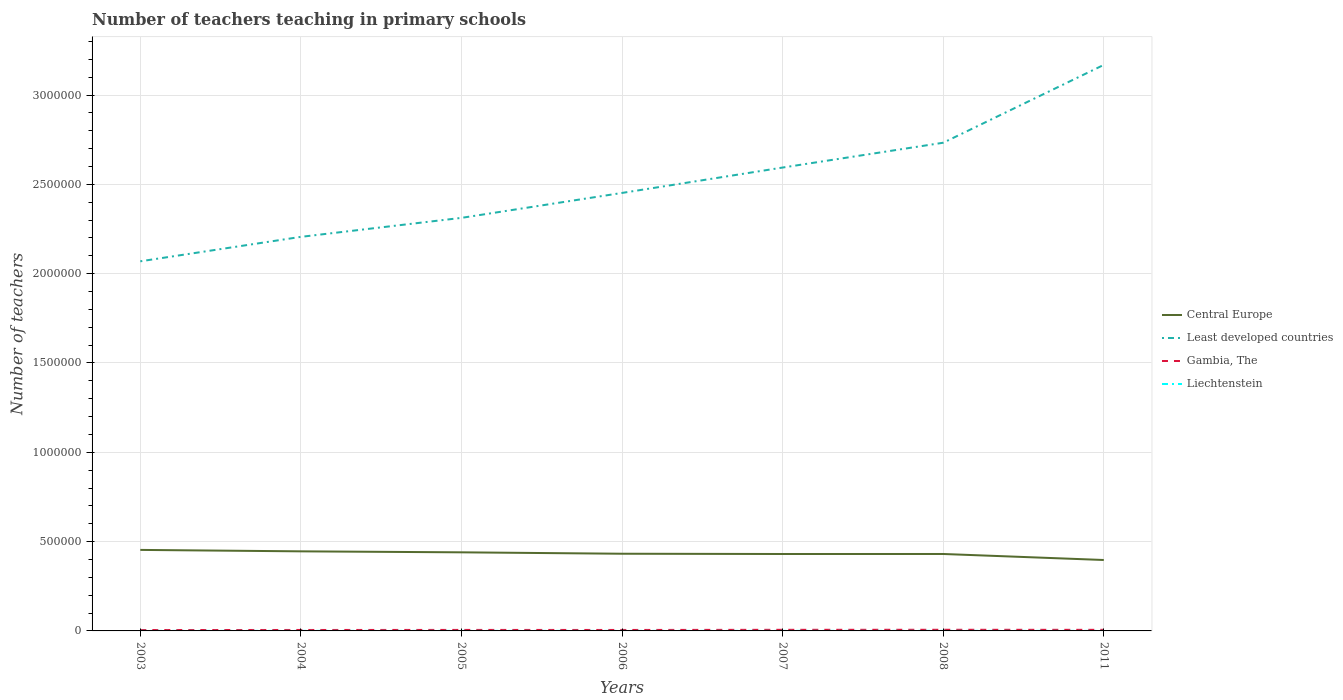How many different coloured lines are there?
Your response must be concise. 4. Is the number of lines equal to the number of legend labels?
Make the answer very short. Yes. Across all years, what is the maximum number of teachers teaching in primary schools in Liechtenstein?
Offer a terse response. 242. What is the difference between the highest and the second highest number of teachers teaching in primary schools in Least developed countries?
Your answer should be very brief. 1.10e+06. What is the difference between the highest and the lowest number of teachers teaching in primary schools in Central Europe?
Provide a succinct answer. 3. Is the number of teachers teaching in primary schools in Central Europe strictly greater than the number of teachers teaching in primary schools in Gambia, The over the years?
Provide a short and direct response. No. How many lines are there?
Ensure brevity in your answer.  4. How many years are there in the graph?
Offer a terse response. 7. How are the legend labels stacked?
Provide a short and direct response. Vertical. What is the title of the graph?
Ensure brevity in your answer.  Number of teachers teaching in primary schools. Does "Japan" appear as one of the legend labels in the graph?
Give a very brief answer. No. What is the label or title of the X-axis?
Provide a succinct answer. Years. What is the label or title of the Y-axis?
Make the answer very short. Number of teachers. What is the Number of teachers of Central Europe in 2003?
Make the answer very short. 4.54e+05. What is the Number of teachers in Least developed countries in 2003?
Your response must be concise. 2.07e+06. What is the Number of teachers in Gambia, The in 2003?
Provide a short and direct response. 4985. What is the Number of teachers of Liechtenstein in 2003?
Your answer should be very brief. 242. What is the Number of teachers of Central Europe in 2004?
Offer a very short reply. 4.45e+05. What is the Number of teachers of Least developed countries in 2004?
Your response must be concise. 2.21e+06. What is the Number of teachers in Gambia, The in 2004?
Give a very brief answer. 5313. What is the Number of teachers in Liechtenstein in 2004?
Your response must be concise. 260. What is the Number of teachers in Central Europe in 2005?
Your answer should be very brief. 4.40e+05. What is the Number of teachers in Least developed countries in 2005?
Ensure brevity in your answer.  2.31e+06. What is the Number of teachers of Gambia, The in 2005?
Your response must be concise. 5616. What is the Number of teachers of Liechtenstein in 2005?
Ensure brevity in your answer.  260. What is the Number of teachers of Central Europe in 2006?
Offer a terse response. 4.32e+05. What is the Number of teachers of Least developed countries in 2006?
Give a very brief answer. 2.45e+06. What is the Number of teachers of Gambia, The in 2006?
Offer a terse response. 5392. What is the Number of teachers of Liechtenstein in 2006?
Offer a very short reply. 268. What is the Number of teachers in Central Europe in 2007?
Give a very brief answer. 4.31e+05. What is the Number of teachers in Least developed countries in 2007?
Keep it short and to the point. 2.59e+06. What is the Number of teachers of Gambia, The in 2007?
Your answer should be compact. 6219. What is the Number of teachers in Liechtenstein in 2007?
Your response must be concise. 315. What is the Number of teachers of Central Europe in 2008?
Give a very brief answer. 4.31e+05. What is the Number of teachers in Least developed countries in 2008?
Keep it short and to the point. 2.73e+06. What is the Number of teachers of Gambia, The in 2008?
Ensure brevity in your answer.  6429. What is the Number of teachers in Liechtenstein in 2008?
Provide a short and direct response. 332. What is the Number of teachers of Central Europe in 2011?
Your answer should be compact. 3.97e+05. What is the Number of teachers of Least developed countries in 2011?
Your answer should be very brief. 3.17e+06. What is the Number of teachers of Gambia, The in 2011?
Offer a terse response. 6074. What is the Number of teachers of Liechtenstein in 2011?
Ensure brevity in your answer.  257. Across all years, what is the maximum Number of teachers in Central Europe?
Ensure brevity in your answer.  4.54e+05. Across all years, what is the maximum Number of teachers of Least developed countries?
Give a very brief answer. 3.17e+06. Across all years, what is the maximum Number of teachers in Gambia, The?
Offer a terse response. 6429. Across all years, what is the maximum Number of teachers in Liechtenstein?
Your answer should be compact. 332. Across all years, what is the minimum Number of teachers of Central Europe?
Provide a succinct answer. 3.97e+05. Across all years, what is the minimum Number of teachers in Least developed countries?
Ensure brevity in your answer.  2.07e+06. Across all years, what is the minimum Number of teachers in Gambia, The?
Ensure brevity in your answer.  4985. Across all years, what is the minimum Number of teachers of Liechtenstein?
Keep it short and to the point. 242. What is the total Number of teachers in Central Europe in the graph?
Your response must be concise. 3.03e+06. What is the total Number of teachers in Least developed countries in the graph?
Give a very brief answer. 1.75e+07. What is the total Number of teachers of Gambia, The in the graph?
Keep it short and to the point. 4.00e+04. What is the total Number of teachers of Liechtenstein in the graph?
Give a very brief answer. 1934. What is the difference between the Number of teachers in Central Europe in 2003 and that in 2004?
Keep it short and to the point. 8121.78. What is the difference between the Number of teachers of Least developed countries in 2003 and that in 2004?
Your response must be concise. -1.37e+05. What is the difference between the Number of teachers of Gambia, The in 2003 and that in 2004?
Provide a succinct answer. -328. What is the difference between the Number of teachers of Liechtenstein in 2003 and that in 2004?
Give a very brief answer. -18. What is the difference between the Number of teachers of Central Europe in 2003 and that in 2005?
Your response must be concise. 1.36e+04. What is the difference between the Number of teachers of Least developed countries in 2003 and that in 2005?
Offer a very short reply. -2.43e+05. What is the difference between the Number of teachers in Gambia, The in 2003 and that in 2005?
Ensure brevity in your answer.  -631. What is the difference between the Number of teachers in Central Europe in 2003 and that in 2006?
Give a very brief answer. 2.15e+04. What is the difference between the Number of teachers of Least developed countries in 2003 and that in 2006?
Provide a succinct answer. -3.83e+05. What is the difference between the Number of teachers in Gambia, The in 2003 and that in 2006?
Your answer should be compact. -407. What is the difference between the Number of teachers in Central Europe in 2003 and that in 2007?
Your answer should be compact. 2.30e+04. What is the difference between the Number of teachers in Least developed countries in 2003 and that in 2007?
Provide a succinct answer. -5.25e+05. What is the difference between the Number of teachers of Gambia, The in 2003 and that in 2007?
Make the answer very short. -1234. What is the difference between the Number of teachers in Liechtenstein in 2003 and that in 2007?
Keep it short and to the point. -73. What is the difference between the Number of teachers of Central Europe in 2003 and that in 2008?
Your response must be concise. 2.29e+04. What is the difference between the Number of teachers in Least developed countries in 2003 and that in 2008?
Provide a short and direct response. -6.64e+05. What is the difference between the Number of teachers of Gambia, The in 2003 and that in 2008?
Keep it short and to the point. -1444. What is the difference between the Number of teachers of Liechtenstein in 2003 and that in 2008?
Keep it short and to the point. -90. What is the difference between the Number of teachers in Central Europe in 2003 and that in 2011?
Provide a succinct answer. 5.65e+04. What is the difference between the Number of teachers of Least developed countries in 2003 and that in 2011?
Your answer should be compact. -1.10e+06. What is the difference between the Number of teachers of Gambia, The in 2003 and that in 2011?
Make the answer very short. -1089. What is the difference between the Number of teachers of Central Europe in 2004 and that in 2005?
Give a very brief answer. 5439.44. What is the difference between the Number of teachers in Least developed countries in 2004 and that in 2005?
Provide a short and direct response. -1.06e+05. What is the difference between the Number of teachers of Gambia, The in 2004 and that in 2005?
Your answer should be compact. -303. What is the difference between the Number of teachers in Central Europe in 2004 and that in 2006?
Offer a terse response. 1.34e+04. What is the difference between the Number of teachers in Least developed countries in 2004 and that in 2006?
Give a very brief answer. -2.46e+05. What is the difference between the Number of teachers in Gambia, The in 2004 and that in 2006?
Provide a succinct answer. -79. What is the difference between the Number of teachers in Liechtenstein in 2004 and that in 2006?
Give a very brief answer. -8. What is the difference between the Number of teachers in Central Europe in 2004 and that in 2007?
Your response must be concise. 1.49e+04. What is the difference between the Number of teachers in Least developed countries in 2004 and that in 2007?
Provide a short and direct response. -3.88e+05. What is the difference between the Number of teachers in Gambia, The in 2004 and that in 2007?
Keep it short and to the point. -906. What is the difference between the Number of teachers in Liechtenstein in 2004 and that in 2007?
Provide a short and direct response. -55. What is the difference between the Number of teachers in Central Europe in 2004 and that in 2008?
Provide a succinct answer. 1.47e+04. What is the difference between the Number of teachers in Least developed countries in 2004 and that in 2008?
Ensure brevity in your answer.  -5.27e+05. What is the difference between the Number of teachers in Gambia, The in 2004 and that in 2008?
Provide a short and direct response. -1116. What is the difference between the Number of teachers in Liechtenstein in 2004 and that in 2008?
Make the answer very short. -72. What is the difference between the Number of teachers in Central Europe in 2004 and that in 2011?
Ensure brevity in your answer.  4.84e+04. What is the difference between the Number of teachers in Least developed countries in 2004 and that in 2011?
Make the answer very short. -9.63e+05. What is the difference between the Number of teachers in Gambia, The in 2004 and that in 2011?
Your answer should be very brief. -761. What is the difference between the Number of teachers of Liechtenstein in 2004 and that in 2011?
Provide a succinct answer. 3. What is the difference between the Number of teachers in Central Europe in 2005 and that in 2006?
Offer a very short reply. 7940.81. What is the difference between the Number of teachers of Least developed countries in 2005 and that in 2006?
Keep it short and to the point. -1.40e+05. What is the difference between the Number of teachers of Gambia, The in 2005 and that in 2006?
Ensure brevity in your answer.  224. What is the difference between the Number of teachers in Liechtenstein in 2005 and that in 2006?
Provide a short and direct response. -8. What is the difference between the Number of teachers in Central Europe in 2005 and that in 2007?
Offer a terse response. 9410.81. What is the difference between the Number of teachers of Least developed countries in 2005 and that in 2007?
Provide a succinct answer. -2.82e+05. What is the difference between the Number of teachers of Gambia, The in 2005 and that in 2007?
Your response must be concise. -603. What is the difference between the Number of teachers of Liechtenstein in 2005 and that in 2007?
Keep it short and to the point. -55. What is the difference between the Number of teachers in Central Europe in 2005 and that in 2008?
Ensure brevity in your answer.  9306.81. What is the difference between the Number of teachers of Least developed countries in 2005 and that in 2008?
Your response must be concise. -4.21e+05. What is the difference between the Number of teachers of Gambia, The in 2005 and that in 2008?
Ensure brevity in your answer.  -813. What is the difference between the Number of teachers of Liechtenstein in 2005 and that in 2008?
Offer a terse response. -72. What is the difference between the Number of teachers of Central Europe in 2005 and that in 2011?
Offer a terse response. 4.30e+04. What is the difference between the Number of teachers in Least developed countries in 2005 and that in 2011?
Offer a terse response. -8.56e+05. What is the difference between the Number of teachers of Gambia, The in 2005 and that in 2011?
Provide a succinct answer. -458. What is the difference between the Number of teachers in Liechtenstein in 2005 and that in 2011?
Your answer should be compact. 3. What is the difference between the Number of teachers in Central Europe in 2006 and that in 2007?
Keep it short and to the point. 1470. What is the difference between the Number of teachers in Least developed countries in 2006 and that in 2007?
Make the answer very short. -1.42e+05. What is the difference between the Number of teachers of Gambia, The in 2006 and that in 2007?
Ensure brevity in your answer.  -827. What is the difference between the Number of teachers in Liechtenstein in 2006 and that in 2007?
Offer a terse response. -47. What is the difference between the Number of teachers of Central Europe in 2006 and that in 2008?
Make the answer very short. 1366. What is the difference between the Number of teachers in Least developed countries in 2006 and that in 2008?
Give a very brief answer. -2.81e+05. What is the difference between the Number of teachers of Gambia, The in 2006 and that in 2008?
Offer a very short reply. -1037. What is the difference between the Number of teachers in Liechtenstein in 2006 and that in 2008?
Ensure brevity in your answer.  -64. What is the difference between the Number of teachers of Central Europe in 2006 and that in 2011?
Offer a terse response. 3.50e+04. What is the difference between the Number of teachers of Least developed countries in 2006 and that in 2011?
Offer a very short reply. -7.17e+05. What is the difference between the Number of teachers in Gambia, The in 2006 and that in 2011?
Provide a succinct answer. -682. What is the difference between the Number of teachers in Central Europe in 2007 and that in 2008?
Give a very brief answer. -104. What is the difference between the Number of teachers in Least developed countries in 2007 and that in 2008?
Provide a short and direct response. -1.39e+05. What is the difference between the Number of teachers of Gambia, The in 2007 and that in 2008?
Offer a terse response. -210. What is the difference between the Number of teachers in Central Europe in 2007 and that in 2011?
Provide a short and direct response. 3.36e+04. What is the difference between the Number of teachers of Least developed countries in 2007 and that in 2011?
Offer a terse response. -5.75e+05. What is the difference between the Number of teachers in Gambia, The in 2007 and that in 2011?
Your response must be concise. 145. What is the difference between the Number of teachers in Central Europe in 2008 and that in 2011?
Keep it short and to the point. 3.37e+04. What is the difference between the Number of teachers in Least developed countries in 2008 and that in 2011?
Your answer should be very brief. -4.36e+05. What is the difference between the Number of teachers of Gambia, The in 2008 and that in 2011?
Keep it short and to the point. 355. What is the difference between the Number of teachers in Central Europe in 2003 and the Number of teachers in Least developed countries in 2004?
Give a very brief answer. -1.75e+06. What is the difference between the Number of teachers in Central Europe in 2003 and the Number of teachers in Gambia, The in 2004?
Make the answer very short. 4.48e+05. What is the difference between the Number of teachers of Central Europe in 2003 and the Number of teachers of Liechtenstein in 2004?
Your answer should be very brief. 4.53e+05. What is the difference between the Number of teachers in Least developed countries in 2003 and the Number of teachers in Gambia, The in 2004?
Offer a very short reply. 2.06e+06. What is the difference between the Number of teachers in Least developed countries in 2003 and the Number of teachers in Liechtenstein in 2004?
Your answer should be very brief. 2.07e+06. What is the difference between the Number of teachers in Gambia, The in 2003 and the Number of teachers in Liechtenstein in 2004?
Offer a very short reply. 4725. What is the difference between the Number of teachers of Central Europe in 2003 and the Number of teachers of Least developed countries in 2005?
Make the answer very short. -1.86e+06. What is the difference between the Number of teachers of Central Europe in 2003 and the Number of teachers of Gambia, The in 2005?
Ensure brevity in your answer.  4.48e+05. What is the difference between the Number of teachers of Central Europe in 2003 and the Number of teachers of Liechtenstein in 2005?
Your response must be concise. 4.53e+05. What is the difference between the Number of teachers of Least developed countries in 2003 and the Number of teachers of Gambia, The in 2005?
Provide a succinct answer. 2.06e+06. What is the difference between the Number of teachers in Least developed countries in 2003 and the Number of teachers in Liechtenstein in 2005?
Offer a very short reply. 2.07e+06. What is the difference between the Number of teachers in Gambia, The in 2003 and the Number of teachers in Liechtenstein in 2005?
Provide a succinct answer. 4725. What is the difference between the Number of teachers of Central Europe in 2003 and the Number of teachers of Least developed countries in 2006?
Provide a short and direct response. -2.00e+06. What is the difference between the Number of teachers of Central Europe in 2003 and the Number of teachers of Gambia, The in 2006?
Offer a terse response. 4.48e+05. What is the difference between the Number of teachers of Central Europe in 2003 and the Number of teachers of Liechtenstein in 2006?
Keep it short and to the point. 4.53e+05. What is the difference between the Number of teachers in Least developed countries in 2003 and the Number of teachers in Gambia, The in 2006?
Offer a very short reply. 2.06e+06. What is the difference between the Number of teachers in Least developed countries in 2003 and the Number of teachers in Liechtenstein in 2006?
Ensure brevity in your answer.  2.07e+06. What is the difference between the Number of teachers in Gambia, The in 2003 and the Number of teachers in Liechtenstein in 2006?
Provide a succinct answer. 4717. What is the difference between the Number of teachers of Central Europe in 2003 and the Number of teachers of Least developed countries in 2007?
Keep it short and to the point. -2.14e+06. What is the difference between the Number of teachers in Central Europe in 2003 and the Number of teachers in Gambia, The in 2007?
Provide a succinct answer. 4.47e+05. What is the difference between the Number of teachers in Central Europe in 2003 and the Number of teachers in Liechtenstein in 2007?
Offer a very short reply. 4.53e+05. What is the difference between the Number of teachers in Least developed countries in 2003 and the Number of teachers in Gambia, The in 2007?
Make the answer very short. 2.06e+06. What is the difference between the Number of teachers of Least developed countries in 2003 and the Number of teachers of Liechtenstein in 2007?
Your answer should be very brief. 2.07e+06. What is the difference between the Number of teachers of Gambia, The in 2003 and the Number of teachers of Liechtenstein in 2007?
Ensure brevity in your answer.  4670. What is the difference between the Number of teachers of Central Europe in 2003 and the Number of teachers of Least developed countries in 2008?
Offer a terse response. -2.28e+06. What is the difference between the Number of teachers of Central Europe in 2003 and the Number of teachers of Gambia, The in 2008?
Your answer should be very brief. 4.47e+05. What is the difference between the Number of teachers in Central Europe in 2003 and the Number of teachers in Liechtenstein in 2008?
Provide a short and direct response. 4.53e+05. What is the difference between the Number of teachers in Least developed countries in 2003 and the Number of teachers in Gambia, The in 2008?
Your answer should be very brief. 2.06e+06. What is the difference between the Number of teachers of Least developed countries in 2003 and the Number of teachers of Liechtenstein in 2008?
Keep it short and to the point. 2.07e+06. What is the difference between the Number of teachers of Gambia, The in 2003 and the Number of teachers of Liechtenstein in 2008?
Give a very brief answer. 4653. What is the difference between the Number of teachers of Central Europe in 2003 and the Number of teachers of Least developed countries in 2011?
Keep it short and to the point. -2.72e+06. What is the difference between the Number of teachers in Central Europe in 2003 and the Number of teachers in Gambia, The in 2011?
Your answer should be very brief. 4.48e+05. What is the difference between the Number of teachers in Central Europe in 2003 and the Number of teachers in Liechtenstein in 2011?
Offer a terse response. 4.53e+05. What is the difference between the Number of teachers in Least developed countries in 2003 and the Number of teachers in Gambia, The in 2011?
Provide a succinct answer. 2.06e+06. What is the difference between the Number of teachers in Least developed countries in 2003 and the Number of teachers in Liechtenstein in 2011?
Your response must be concise. 2.07e+06. What is the difference between the Number of teachers of Gambia, The in 2003 and the Number of teachers of Liechtenstein in 2011?
Provide a short and direct response. 4728. What is the difference between the Number of teachers in Central Europe in 2004 and the Number of teachers in Least developed countries in 2005?
Provide a short and direct response. -1.87e+06. What is the difference between the Number of teachers of Central Europe in 2004 and the Number of teachers of Gambia, The in 2005?
Offer a terse response. 4.40e+05. What is the difference between the Number of teachers in Central Europe in 2004 and the Number of teachers in Liechtenstein in 2005?
Make the answer very short. 4.45e+05. What is the difference between the Number of teachers in Least developed countries in 2004 and the Number of teachers in Gambia, The in 2005?
Offer a terse response. 2.20e+06. What is the difference between the Number of teachers in Least developed countries in 2004 and the Number of teachers in Liechtenstein in 2005?
Offer a terse response. 2.21e+06. What is the difference between the Number of teachers in Gambia, The in 2004 and the Number of teachers in Liechtenstein in 2005?
Your response must be concise. 5053. What is the difference between the Number of teachers of Central Europe in 2004 and the Number of teachers of Least developed countries in 2006?
Ensure brevity in your answer.  -2.01e+06. What is the difference between the Number of teachers in Central Europe in 2004 and the Number of teachers in Gambia, The in 2006?
Offer a terse response. 4.40e+05. What is the difference between the Number of teachers of Central Europe in 2004 and the Number of teachers of Liechtenstein in 2006?
Your response must be concise. 4.45e+05. What is the difference between the Number of teachers of Least developed countries in 2004 and the Number of teachers of Gambia, The in 2006?
Keep it short and to the point. 2.20e+06. What is the difference between the Number of teachers in Least developed countries in 2004 and the Number of teachers in Liechtenstein in 2006?
Ensure brevity in your answer.  2.21e+06. What is the difference between the Number of teachers in Gambia, The in 2004 and the Number of teachers in Liechtenstein in 2006?
Make the answer very short. 5045. What is the difference between the Number of teachers of Central Europe in 2004 and the Number of teachers of Least developed countries in 2007?
Your response must be concise. -2.15e+06. What is the difference between the Number of teachers of Central Europe in 2004 and the Number of teachers of Gambia, The in 2007?
Your answer should be very brief. 4.39e+05. What is the difference between the Number of teachers of Central Europe in 2004 and the Number of teachers of Liechtenstein in 2007?
Your response must be concise. 4.45e+05. What is the difference between the Number of teachers of Least developed countries in 2004 and the Number of teachers of Gambia, The in 2007?
Ensure brevity in your answer.  2.20e+06. What is the difference between the Number of teachers in Least developed countries in 2004 and the Number of teachers in Liechtenstein in 2007?
Keep it short and to the point. 2.21e+06. What is the difference between the Number of teachers of Gambia, The in 2004 and the Number of teachers of Liechtenstein in 2007?
Make the answer very short. 4998. What is the difference between the Number of teachers of Central Europe in 2004 and the Number of teachers of Least developed countries in 2008?
Offer a very short reply. -2.29e+06. What is the difference between the Number of teachers of Central Europe in 2004 and the Number of teachers of Gambia, The in 2008?
Offer a terse response. 4.39e+05. What is the difference between the Number of teachers in Central Europe in 2004 and the Number of teachers in Liechtenstein in 2008?
Your answer should be compact. 4.45e+05. What is the difference between the Number of teachers of Least developed countries in 2004 and the Number of teachers of Gambia, The in 2008?
Offer a terse response. 2.20e+06. What is the difference between the Number of teachers of Least developed countries in 2004 and the Number of teachers of Liechtenstein in 2008?
Offer a very short reply. 2.21e+06. What is the difference between the Number of teachers in Gambia, The in 2004 and the Number of teachers in Liechtenstein in 2008?
Offer a very short reply. 4981. What is the difference between the Number of teachers in Central Europe in 2004 and the Number of teachers in Least developed countries in 2011?
Provide a succinct answer. -2.72e+06. What is the difference between the Number of teachers of Central Europe in 2004 and the Number of teachers of Gambia, The in 2011?
Give a very brief answer. 4.39e+05. What is the difference between the Number of teachers of Central Europe in 2004 and the Number of teachers of Liechtenstein in 2011?
Offer a very short reply. 4.45e+05. What is the difference between the Number of teachers in Least developed countries in 2004 and the Number of teachers in Gambia, The in 2011?
Offer a terse response. 2.20e+06. What is the difference between the Number of teachers in Least developed countries in 2004 and the Number of teachers in Liechtenstein in 2011?
Make the answer very short. 2.21e+06. What is the difference between the Number of teachers of Gambia, The in 2004 and the Number of teachers of Liechtenstein in 2011?
Your response must be concise. 5056. What is the difference between the Number of teachers of Central Europe in 2005 and the Number of teachers of Least developed countries in 2006?
Make the answer very short. -2.01e+06. What is the difference between the Number of teachers in Central Europe in 2005 and the Number of teachers in Gambia, The in 2006?
Make the answer very short. 4.35e+05. What is the difference between the Number of teachers of Central Europe in 2005 and the Number of teachers of Liechtenstein in 2006?
Offer a very short reply. 4.40e+05. What is the difference between the Number of teachers of Least developed countries in 2005 and the Number of teachers of Gambia, The in 2006?
Make the answer very short. 2.31e+06. What is the difference between the Number of teachers of Least developed countries in 2005 and the Number of teachers of Liechtenstein in 2006?
Offer a very short reply. 2.31e+06. What is the difference between the Number of teachers of Gambia, The in 2005 and the Number of teachers of Liechtenstein in 2006?
Offer a very short reply. 5348. What is the difference between the Number of teachers in Central Europe in 2005 and the Number of teachers in Least developed countries in 2007?
Your answer should be very brief. -2.15e+06. What is the difference between the Number of teachers of Central Europe in 2005 and the Number of teachers of Gambia, The in 2007?
Your answer should be very brief. 4.34e+05. What is the difference between the Number of teachers in Central Europe in 2005 and the Number of teachers in Liechtenstein in 2007?
Your response must be concise. 4.40e+05. What is the difference between the Number of teachers in Least developed countries in 2005 and the Number of teachers in Gambia, The in 2007?
Your answer should be compact. 2.31e+06. What is the difference between the Number of teachers in Least developed countries in 2005 and the Number of teachers in Liechtenstein in 2007?
Your answer should be compact. 2.31e+06. What is the difference between the Number of teachers of Gambia, The in 2005 and the Number of teachers of Liechtenstein in 2007?
Give a very brief answer. 5301. What is the difference between the Number of teachers of Central Europe in 2005 and the Number of teachers of Least developed countries in 2008?
Your response must be concise. -2.29e+06. What is the difference between the Number of teachers in Central Europe in 2005 and the Number of teachers in Gambia, The in 2008?
Your answer should be very brief. 4.34e+05. What is the difference between the Number of teachers of Central Europe in 2005 and the Number of teachers of Liechtenstein in 2008?
Offer a terse response. 4.40e+05. What is the difference between the Number of teachers of Least developed countries in 2005 and the Number of teachers of Gambia, The in 2008?
Make the answer very short. 2.31e+06. What is the difference between the Number of teachers of Least developed countries in 2005 and the Number of teachers of Liechtenstein in 2008?
Keep it short and to the point. 2.31e+06. What is the difference between the Number of teachers in Gambia, The in 2005 and the Number of teachers in Liechtenstein in 2008?
Ensure brevity in your answer.  5284. What is the difference between the Number of teachers of Central Europe in 2005 and the Number of teachers of Least developed countries in 2011?
Keep it short and to the point. -2.73e+06. What is the difference between the Number of teachers in Central Europe in 2005 and the Number of teachers in Gambia, The in 2011?
Give a very brief answer. 4.34e+05. What is the difference between the Number of teachers of Central Europe in 2005 and the Number of teachers of Liechtenstein in 2011?
Provide a succinct answer. 4.40e+05. What is the difference between the Number of teachers of Least developed countries in 2005 and the Number of teachers of Gambia, The in 2011?
Provide a succinct answer. 2.31e+06. What is the difference between the Number of teachers in Least developed countries in 2005 and the Number of teachers in Liechtenstein in 2011?
Your answer should be compact. 2.31e+06. What is the difference between the Number of teachers in Gambia, The in 2005 and the Number of teachers in Liechtenstein in 2011?
Provide a short and direct response. 5359. What is the difference between the Number of teachers in Central Europe in 2006 and the Number of teachers in Least developed countries in 2007?
Ensure brevity in your answer.  -2.16e+06. What is the difference between the Number of teachers in Central Europe in 2006 and the Number of teachers in Gambia, The in 2007?
Ensure brevity in your answer.  4.26e+05. What is the difference between the Number of teachers of Central Europe in 2006 and the Number of teachers of Liechtenstein in 2007?
Offer a terse response. 4.32e+05. What is the difference between the Number of teachers in Least developed countries in 2006 and the Number of teachers in Gambia, The in 2007?
Make the answer very short. 2.45e+06. What is the difference between the Number of teachers in Least developed countries in 2006 and the Number of teachers in Liechtenstein in 2007?
Make the answer very short. 2.45e+06. What is the difference between the Number of teachers of Gambia, The in 2006 and the Number of teachers of Liechtenstein in 2007?
Keep it short and to the point. 5077. What is the difference between the Number of teachers of Central Europe in 2006 and the Number of teachers of Least developed countries in 2008?
Offer a very short reply. -2.30e+06. What is the difference between the Number of teachers in Central Europe in 2006 and the Number of teachers in Gambia, The in 2008?
Your answer should be compact. 4.26e+05. What is the difference between the Number of teachers of Central Europe in 2006 and the Number of teachers of Liechtenstein in 2008?
Keep it short and to the point. 4.32e+05. What is the difference between the Number of teachers of Least developed countries in 2006 and the Number of teachers of Gambia, The in 2008?
Provide a succinct answer. 2.45e+06. What is the difference between the Number of teachers in Least developed countries in 2006 and the Number of teachers in Liechtenstein in 2008?
Offer a very short reply. 2.45e+06. What is the difference between the Number of teachers in Gambia, The in 2006 and the Number of teachers in Liechtenstein in 2008?
Provide a short and direct response. 5060. What is the difference between the Number of teachers of Central Europe in 2006 and the Number of teachers of Least developed countries in 2011?
Provide a succinct answer. -2.74e+06. What is the difference between the Number of teachers in Central Europe in 2006 and the Number of teachers in Gambia, The in 2011?
Give a very brief answer. 4.26e+05. What is the difference between the Number of teachers in Central Europe in 2006 and the Number of teachers in Liechtenstein in 2011?
Offer a terse response. 4.32e+05. What is the difference between the Number of teachers in Least developed countries in 2006 and the Number of teachers in Gambia, The in 2011?
Provide a short and direct response. 2.45e+06. What is the difference between the Number of teachers in Least developed countries in 2006 and the Number of teachers in Liechtenstein in 2011?
Offer a very short reply. 2.45e+06. What is the difference between the Number of teachers in Gambia, The in 2006 and the Number of teachers in Liechtenstein in 2011?
Keep it short and to the point. 5135. What is the difference between the Number of teachers of Central Europe in 2007 and the Number of teachers of Least developed countries in 2008?
Provide a short and direct response. -2.30e+06. What is the difference between the Number of teachers in Central Europe in 2007 and the Number of teachers in Gambia, The in 2008?
Your answer should be compact. 4.24e+05. What is the difference between the Number of teachers of Central Europe in 2007 and the Number of teachers of Liechtenstein in 2008?
Your answer should be compact. 4.30e+05. What is the difference between the Number of teachers in Least developed countries in 2007 and the Number of teachers in Gambia, The in 2008?
Keep it short and to the point. 2.59e+06. What is the difference between the Number of teachers in Least developed countries in 2007 and the Number of teachers in Liechtenstein in 2008?
Ensure brevity in your answer.  2.59e+06. What is the difference between the Number of teachers of Gambia, The in 2007 and the Number of teachers of Liechtenstein in 2008?
Provide a short and direct response. 5887. What is the difference between the Number of teachers in Central Europe in 2007 and the Number of teachers in Least developed countries in 2011?
Your answer should be very brief. -2.74e+06. What is the difference between the Number of teachers in Central Europe in 2007 and the Number of teachers in Gambia, The in 2011?
Offer a very short reply. 4.25e+05. What is the difference between the Number of teachers in Central Europe in 2007 and the Number of teachers in Liechtenstein in 2011?
Keep it short and to the point. 4.30e+05. What is the difference between the Number of teachers of Least developed countries in 2007 and the Number of teachers of Gambia, The in 2011?
Your answer should be very brief. 2.59e+06. What is the difference between the Number of teachers of Least developed countries in 2007 and the Number of teachers of Liechtenstein in 2011?
Provide a succinct answer. 2.59e+06. What is the difference between the Number of teachers in Gambia, The in 2007 and the Number of teachers in Liechtenstein in 2011?
Make the answer very short. 5962. What is the difference between the Number of teachers in Central Europe in 2008 and the Number of teachers in Least developed countries in 2011?
Your answer should be compact. -2.74e+06. What is the difference between the Number of teachers in Central Europe in 2008 and the Number of teachers in Gambia, The in 2011?
Your response must be concise. 4.25e+05. What is the difference between the Number of teachers in Central Europe in 2008 and the Number of teachers in Liechtenstein in 2011?
Give a very brief answer. 4.30e+05. What is the difference between the Number of teachers of Least developed countries in 2008 and the Number of teachers of Gambia, The in 2011?
Keep it short and to the point. 2.73e+06. What is the difference between the Number of teachers in Least developed countries in 2008 and the Number of teachers in Liechtenstein in 2011?
Provide a succinct answer. 2.73e+06. What is the difference between the Number of teachers of Gambia, The in 2008 and the Number of teachers of Liechtenstein in 2011?
Offer a very short reply. 6172. What is the average Number of teachers of Central Europe per year?
Keep it short and to the point. 4.33e+05. What is the average Number of teachers of Least developed countries per year?
Your response must be concise. 2.51e+06. What is the average Number of teachers of Gambia, The per year?
Provide a short and direct response. 5718.29. What is the average Number of teachers in Liechtenstein per year?
Ensure brevity in your answer.  276.29. In the year 2003, what is the difference between the Number of teachers of Central Europe and Number of teachers of Least developed countries?
Your answer should be compact. -1.62e+06. In the year 2003, what is the difference between the Number of teachers of Central Europe and Number of teachers of Gambia, The?
Your response must be concise. 4.49e+05. In the year 2003, what is the difference between the Number of teachers in Central Europe and Number of teachers in Liechtenstein?
Offer a very short reply. 4.53e+05. In the year 2003, what is the difference between the Number of teachers in Least developed countries and Number of teachers in Gambia, The?
Give a very brief answer. 2.06e+06. In the year 2003, what is the difference between the Number of teachers in Least developed countries and Number of teachers in Liechtenstein?
Provide a short and direct response. 2.07e+06. In the year 2003, what is the difference between the Number of teachers in Gambia, The and Number of teachers in Liechtenstein?
Offer a terse response. 4743. In the year 2004, what is the difference between the Number of teachers of Central Europe and Number of teachers of Least developed countries?
Offer a terse response. -1.76e+06. In the year 2004, what is the difference between the Number of teachers of Central Europe and Number of teachers of Gambia, The?
Offer a terse response. 4.40e+05. In the year 2004, what is the difference between the Number of teachers in Central Europe and Number of teachers in Liechtenstein?
Keep it short and to the point. 4.45e+05. In the year 2004, what is the difference between the Number of teachers of Least developed countries and Number of teachers of Gambia, The?
Your answer should be very brief. 2.20e+06. In the year 2004, what is the difference between the Number of teachers in Least developed countries and Number of teachers in Liechtenstein?
Make the answer very short. 2.21e+06. In the year 2004, what is the difference between the Number of teachers in Gambia, The and Number of teachers in Liechtenstein?
Your answer should be very brief. 5053. In the year 2005, what is the difference between the Number of teachers in Central Europe and Number of teachers in Least developed countries?
Provide a short and direct response. -1.87e+06. In the year 2005, what is the difference between the Number of teachers in Central Europe and Number of teachers in Gambia, The?
Your response must be concise. 4.34e+05. In the year 2005, what is the difference between the Number of teachers of Central Europe and Number of teachers of Liechtenstein?
Ensure brevity in your answer.  4.40e+05. In the year 2005, what is the difference between the Number of teachers in Least developed countries and Number of teachers in Gambia, The?
Your response must be concise. 2.31e+06. In the year 2005, what is the difference between the Number of teachers in Least developed countries and Number of teachers in Liechtenstein?
Keep it short and to the point. 2.31e+06. In the year 2005, what is the difference between the Number of teachers of Gambia, The and Number of teachers of Liechtenstein?
Offer a terse response. 5356. In the year 2006, what is the difference between the Number of teachers of Central Europe and Number of teachers of Least developed countries?
Ensure brevity in your answer.  -2.02e+06. In the year 2006, what is the difference between the Number of teachers in Central Europe and Number of teachers in Gambia, The?
Provide a short and direct response. 4.27e+05. In the year 2006, what is the difference between the Number of teachers in Central Europe and Number of teachers in Liechtenstein?
Your answer should be very brief. 4.32e+05. In the year 2006, what is the difference between the Number of teachers of Least developed countries and Number of teachers of Gambia, The?
Give a very brief answer. 2.45e+06. In the year 2006, what is the difference between the Number of teachers in Least developed countries and Number of teachers in Liechtenstein?
Offer a terse response. 2.45e+06. In the year 2006, what is the difference between the Number of teachers of Gambia, The and Number of teachers of Liechtenstein?
Offer a very short reply. 5124. In the year 2007, what is the difference between the Number of teachers of Central Europe and Number of teachers of Least developed countries?
Keep it short and to the point. -2.16e+06. In the year 2007, what is the difference between the Number of teachers of Central Europe and Number of teachers of Gambia, The?
Keep it short and to the point. 4.24e+05. In the year 2007, what is the difference between the Number of teachers of Central Europe and Number of teachers of Liechtenstein?
Your answer should be compact. 4.30e+05. In the year 2007, what is the difference between the Number of teachers in Least developed countries and Number of teachers in Gambia, The?
Your answer should be compact. 2.59e+06. In the year 2007, what is the difference between the Number of teachers of Least developed countries and Number of teachers of Liechtenstein?
Ensure brevity in your answer.  2.59e+06. In the year 2007, what is the difference between the Number of teachers of Gambia, The and Number of teachers of Liechtenstein?
Your answer should be very brief. 5904. In the year 2008, what is the difference between the Number of teachers in Central Europe and Number of teachers in Least developed countries?
Offer a terse response. -2.30e+06. In the year 2008, what is the difference between the Number of teachers in Central Europe and Number of teachers in Gambia, The?
Make the answer very short. 4.24e+05. In the year 2008, what is the difference between the Number of teachers of Central Europe and Number of teachers of Liechtenstein?
Provide a short and direct response. 4.30e+05. In the year 2008, what is the difference between the Number of teachers of Least developed countries and Number of teachers of Gambia, The?
Your response must be concise. 2.73e+06. In the year 2008, what is the difference between the Number of teachers in Least developed countries and Number of teachers in Liechtenstein?
Offer a very short reply. 2.73e+06. In the year 2008, what is the difference between the Number of teachers of Gambia, The and Number of teachers of Liechtenstein?
Provide a succinct answer. 6097. In the year 2011, what is the difference between the Number of teachers in Central Europe and Number of teachers in Least developed countries?
Your answer should be compact. -2.77e+06. In the year 2011, what is the difference between the Number of teachers in Central Europe and Number of teachers in Gambia, The?
Make the answer very short. 3.91e+05. In the year 2011, what is the difference between the Number of teachers of Central Europe and Number of teachers of Liechtenstein?
Make the answer very short. 3.97e+05. In the year 2011, what is the difference between the Number of teachers of Least developed countries and Number of teachers of Gambia, The?
Keep it short and to the point. 3.16e+06. In the year 2011, what is the difference between the Number of teachers in Least developed countries and Number of teachers in Liechtenstein?
Offer a terse response. 3.17e+06. In the year 2011, what is the difference between the Number of teachers of Gambia, The and Number of teachers of Liechtenstein?
Ensure brevity in your answer.  5817. What is the ratio of the Number of teachers in Central Europe in 2003 to that in 2004?
Give a very brief answer. 1.02. What is the ratio of the Number of teachers in Least developed countries in 2003 to that in 2004?
Provide a succinct answer. 0.94. What is the ratio of the Number of teachers in Gambia, The in 2003 to that in 2004?
Your answer should be compact. 0.94. What is the ratio of the Number of teachers of Liechtenstein in 2003 to that in 2004?
Your answer should be very brief. 0.93. What is the ratio of the Number of teachers of Central Europe in 2003 to that in 2005?
Make the answer very short. 1.03. What is the ratio of the Number of teachers of Least developed countries in 2003 to that in 2005?
Your response must be concise. 0.89. What is the ratio of the Number of teachers of Gambia, The in 2003 to that in 2005?
Provide a short and direct response. 0.89. What is the ratio of the Number of teachers in Liechtenstein in 2003 to that in 2005?
Make the answer very short. 0.93. What is the ratio of the Number of teachers in Central Europe in 2003 to that in 2006?
Keep it short and to the point. 1.05. What is the ratio of the Number of teachers of Least developed countries in 2003 to that in 2006?
Keep it short and to the point. 0.84. What is the ratio of the Number of teachers of Gambia, The in 2003 to that in 2006?
Your answer should be compact. 0.92. What is the ratio of the Number of teachers of Liechtenstein in 2003 to that in 2006?
Give a very brief answer. 0.9. What is the ratio of the Number of teachers in Central Europe in 2003 to that in 2007?
Offer a terse response. 1.05. What is the ratio of the Number of teachers of Least developed countries in 2003 to that in 2007?
Make the answer very short. 0.8. What is the ratio of the Number of teachers of Gambia, The in 2003 to that in 2007?
Make the answer very short. 0.8. What is the ratio of the Number of teachers in Liechtenstein in 2003 to that in 2007?
Provide a succinct answer. 0.77. What is the ratio of the Number of teachers in Central Europe in 2003 to that in 2008?
Make the answer very short. 1.05. What is the ratio of the Number of teachers in Least developed countries in 2003 to that in 2008?
Provide a short and direct response. 0.76. What is the ratio of the Number of teachers of Gambia, The in 2003 to that in 2008?
Make the answer very short. 0.78. What is the ratio of the Number of teachers of Liechtenstein in 2003 to that in 2008?
Your answer should be compact. 0.73. What is the ratio of the Number of teachers of Central Europe in 2003 to that in 2011?
Your answer should be compact. 1.14. What is the ratio of the Number of teachers in Least developed countries in 2003 to that in 2011?
Offer a very short reply. 0.65. What is the ratio of the Number of teachers of Gambia, The in 2003 to that in 2011?
Keep it short and to the point. 0.82. What is the ratio of the Number of teachers of Liechtenstein in 2003 to that in 2011?
Offer a terse response. 0.94. What is the ratio of the Number of teachers in Central Europe in 2004 to that in 2005?
Ensure brevity in your answer.  1.01. What is the ratio of the Number of teachers in Least developed countries in 2004 to that in 2005?
Your answer should be very brief. 0.95. What is the ratio of the Number of teachers in Gambia, The in 2004 to that in 2005?
Keep it short and to the point. 0.95. What is the ratio of the Number of teachers of Liechtenstein in 2004 to that in 2005?
Keep it short and to the point. 1. What is the ratio of the Number of teachers of Central Europe in 2004 to that in 2006?
Your response must be concise. 1.03. What is the ratio of the Number of teachers of Least developed countries in 2004 to that in 2006?
Offer a very short reply. 0.9. What is the ratio of the Number of teachers in Gambia, The in 2004 to that in 2006?
Your response must be concise. 0.99. What is the ratio of the Number of teachers of Liechtenstein in 2004 to that in 2006?
Offer a terse response. 0.97. What is the ratio of the Number of teachers in Central Europe in 2004 to that in 2007?
Your answer should be very brief. 1.03. What is the ratio of the Number of teachers in Least developed countries in 2004 to that in 2007?
Give a very brief answer. 0.85. What is the ratio of the Number of teachers in Gambia, The in 2004 to that in 2007?
Ensure brevity in your answer.  0.85. What is the ratio of the Number of teachers of Liechtenstein in 2004 to that in 2007?
Give a very brief answer. 0.83. What is the ratio of the Number of teachers of Central Europe in 2004 to that in 2008?
Your answer should be compact. 1.03. What is the ratio of the Number of teachers in Least developed countries in 2004 to that in 2008?
Provide a short and direct response. 0.81. What is the ratio of the Number of teachers of Gambia, The in 2004 to that in 2008?
Your answer should be compact. 0.83. What is the ratio of the Number of teachers in Liechtenstein in 2004 to that in 2008?
Give a very brief answer. 0.78. What is the ratio of the Number of teachers in Central Europe in 2004 to that in 2011?
Keep it short and to the point. 1.12. What is the ratio of the Number of teachers in Least developed countries in 2004 to that in 2011?
Your response must be concise. 0.7. What is the ratio of the Number of teachers in Gambia, The in 2004 to that in 2011?
Make the answer very short. 0.87. What is the ratio of the Number of teachers in Liechtenstein in 2004 to that in 2011?
Give a very brief answer. 1.01. What is the ratio of the Number of teachers of Central Europe in 2005 to that in 2006?
Your answer should be very brief. 1.02. What is the ratio of the Number of teachers of Least developed countries in 2005 to that in 2006?
Offer a terse response. 0.94. What is the ratio of the Number of teachers in Gambia, The in 2005 to that in 2006?
Ensure brevity in your answer.  1.04. What is the ratio of the Number of teachers of Liechtenstein in 2005 to that in 2006?
Your response must be concise. 0.97. What is the ratio of the Number of teachers of Central Europe in 2005 to that in 2007?
Offer a very short reply. 1.02. What is the ratio of the Number of teachers of Least developed countries in 2005 to that in 2007?
Your answer should be very brief. 0.89. What is the ratio of the Number of teachers of Gambia, The in 2005 to that in 2007?
Your answer should be compact. 0.9. What is the ratio of the Number of teachers in Liechtenstein in 2005 to that in 2007?
Keep it short and to the point. 0.83. What is the ratio of the Number of teachers in Central Europe in 2005 to that in 2008?
Ensure brevity in your answer.  1.02. What is the ratio of the Number of teachers in Least developed countries in 2005 to that in 2008?
Your answer should be compact. 0.85. What is the ratio of the Number of teachers in Gambia, The in 2005 to that in 2008?
Your answer should be very brief. 0.87. What is the ratio of the Number of teachers of Liechtenstein in 2005 to that in 2008?
Keep it short and to the point. 0.78. What is the ratio of the Number of teachers in Central Europe in 2005 to that in 2011?
Give a very brief answer. 1.11. What is the ratio of the Number of teachers in Least developed countries in 2005 to that in 2011?
Your response must be concise. 0.73. What is the ratio of the Number of teachers in Gambia, The in 2005 to that in 2011?
Your response must be concise. 0.92. What is the ratio of the Number of teachers in Liechtenstein in 2005 to that in 2011?
Your response must be concise. 1.01. What is the ratio of the Number of teachers in Central Europe in 2006 to that in 2007?
Your response must be concise. 1. What is the ratio of the Number of teachers in Least developed countries in 2006 to that in 2007?
Ensure brevity in your answer.  0.95. What is the ratio of the Number of teachers of Gambia, The in 2006 to that in 2007?
Give a very brief answer. 0.87. What is the ratio of the Number of teachers of Liechtenstein in 2006 to that in 2007?
Give a very brief answer. 0.85. What is the ratio of the Number of teachers of Least developed countries in 2006 to that in 2008?
Make the answer very short. 0.9. What is the ratio of the Number of teachers in Gambia, The in 2006 to that in 2008?
Offer a very short reply. 0.84. What is the ratio of the Number of teachers in Liechtenstein in 2006 to that in 2008?
Ensure brevity in your answer.  0.81. What is the ratio of the Number of teachers of Central Europe in 2006 to that in 2011?
Ensure brevity in your answer.  1.09. What is the ratio of the Number of teachers in Least developed countries in 2006 to that in 2011?
Keep it short and to the point. 0.77. What is the ratio of the Number of teachers of Gambia, The in 2006 to that in 2011?
Give a very brief answer. 0.89. What is the ratio of the Number of teachers in Liechtenstein in 2006 to that in 2011?
Make the answer very short. 1.04. What is the ratio of the Number of teachers of Central Europe in 2007 to that in 2008?
Offer a very short reply. 1. What is the ratio of the Number of teachers in Least developed countries in 2007 to that in 2008?
Offer a very short reply. 0.95. What is the ratio of the Number of teachers in Gambia, The in 2007 to that in 2008?
Your answer should be compact. 0.97. What is the ratio of the Number of teachers in Liechtenstein in 2007 to that in 2008?
Keep it short and to the point. 0.95. What is the ratio of the Number of teachers in Central Europe in 2007 to that in 2011?
Your answer should be very brief. 1.08. What is the ratio of the Number of teachers in Least developed countries in 2007 to that in 2011?
Your answer should be very brief. 0.82. What is the ratio of the Number of teachers of Gambia, The in 2007 to that in 2011?
Offer a very short reply. 1.02. What is the ratio of the Number of teachers in Liechtenstein in 2007 to that in 2011?
Keep it short and to the point. 1.23. What is the ratio of the Number of teachers of Central Europe in 2008 to that in 2011?
Offer a very short reply. 1.08. What is the ratio of the Number of teachers of Least developed countries in 2008 to that in 2011?
Ensure brevity in your answer.  0.86. What is the ratio of the Number of teachers of Gambia, The in 2008 to that in 2011?
Provide a short and direct response. 1.06. What is the ratio of the Number of teachers of Liechtenstein in 2008 to that in 2011?
Your response must be concise. 1.29. What is the difference between the highest and the second highest Number of teachers of Central Europe?
Provide a short and direct response. 8121.78. What is the difference between the highest and the second highest Number of teachers of Least developed countries?
Your answer should be compact. 4.36e+05. What is the difference between the highest and the second highest Number of teachers of Gambia, The?
Make the answer very short. 210. What is the difference between the highest and the lowest Number of teachers in Central Europe?
Your answer should be very brief. 5.65e+04. What is the difference between the highest and the lowest Number of teachers of Least developed countries?
Your answer should be very brief. 1.10e+06. What is the difference between the highest and the lowest Number of teachers in Gambia, The?
Offer a very short reply. 1444. What is the difference between the highest and the lowest Number of teachers in Liechtenstein?
Your answer should be very brief. 90. 